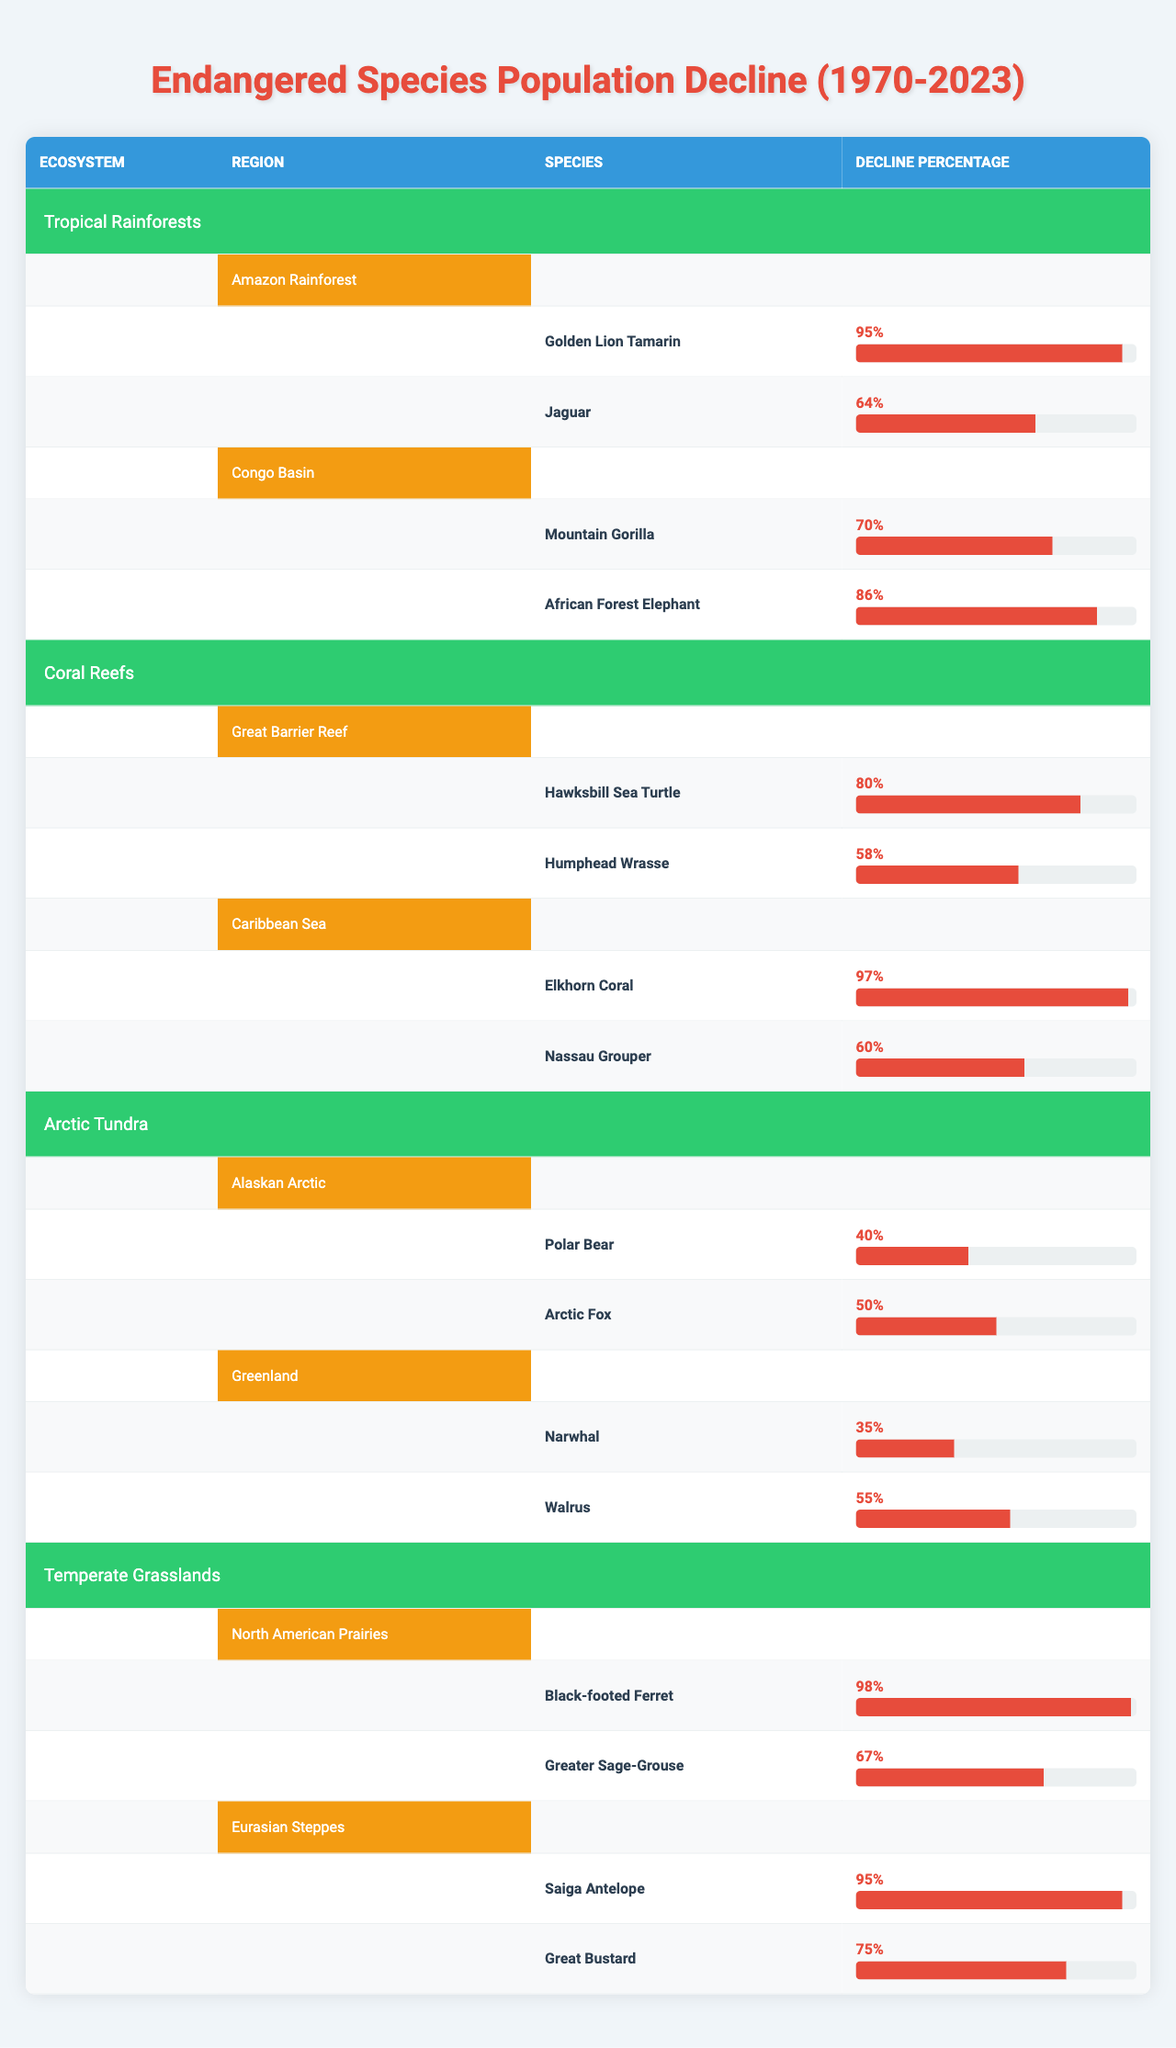What is the species with the highest population decline in Tropical Rainforests? The species with the highest population decline in Tropical Rainforests can be found by comparing the decline percentages of species in that ecosystem. The Golden Lion Tamarin has a decline of 95%, which is higher than the 64% decline of the Jaguar.
Answer: Golden Lion Tamarin Which ecosystem has the least species with a population decline over 50%? To determine which ecosystem has the least species with a decline over 50%, we can look through each ecosystem and count the species that have a decline percentage greater than 50%. The Arctic Tundra has only one species (the Polar Bear) below that threshold, making it the ecosystem with the least such species.
Answer: Arctic Tundra What is the average decline percentage of endangered species in Coral Reefs? The average decline percentage is calculated by taking the decline percentages of species in Coral Reefs (80%, 58%, 97%, and 60%), summing them up to get 295%, and dividing by the total number of species (4). So, 295% divided by 4 gives an average of 73.75%.
Answer: 73.75% Is the population decline of the Elkhorn Coral greater than that of any species in the Arctic Tundra? The Elkhorn Coral has a population decline of 97%. In the Arctic Tundra, the highest decline is 55% (Walrus), which is less than 97%. Therefore, yes, the population decline of the Elkhorn Coral is greater than that of any species in the Arctic Tundra.
Answer: Yes What is the total percentage decline of endangered species in Temperate Grasslands? To find the total decline percentage for Temperate Grasslands, we add the decline percentages of the Black-footed Ferret (98%) and Greater Sage-Grouse (67%), which gives us a total of 165%.
Answer: 165% Which region has the highest percentage of species decline and what is that percentage? We compare the highest decline percentages from all regions. The Caribbean Sea has the highest decline percentage with the Elkhorn Coral at 97%. This percentage is higher than any other region in the table.
Answer: 97% Which species have a population decline less than 60% in the Arctic Tundra? In the Arctic Tundra, the species with a decline below 60% are Narwhal (35%) and Polar Bear (40%). The Arctic Fox (50%) also falls under this category. Therefore, these three species have a decline of less than 60%.
Answer: Narwhal, Polar Bear, Arctic Fox What is the difference in decline percentage between the Mountain Gorilla and the African Forest Elephant? The decline percentage for the Mountain Gorilla is 70% and for the African Forest Elephant, it is 86%. The difference can be calculated by subtracting the Mountain Gorilla's decline from the African Forest Elephant's decline, which gives us 86% - 70% = 16%.
Answer: 16% How many species have a decline percentage of 60% or greater in the Amazon Rainforest? In the Amazon Rainforest, we check each species. The Golden Lion Tamarin has a decline of 95%, and the Jaguar has a decline of 64%. Both exceed 60%, hence there are two species with a decline of that magnitude.
Answer: 2 Which is the only species in the Arctic Tundra with a decline of 40% or greater? In the Arctic Tundra, we check the decline percentages. The Polar Bear has a 40% decline, and the Arctic Fox, with a decline of 50%, also qualifies. Therefore, there are two species: Polar Bear and Arctic Fox.
Answer: 2 